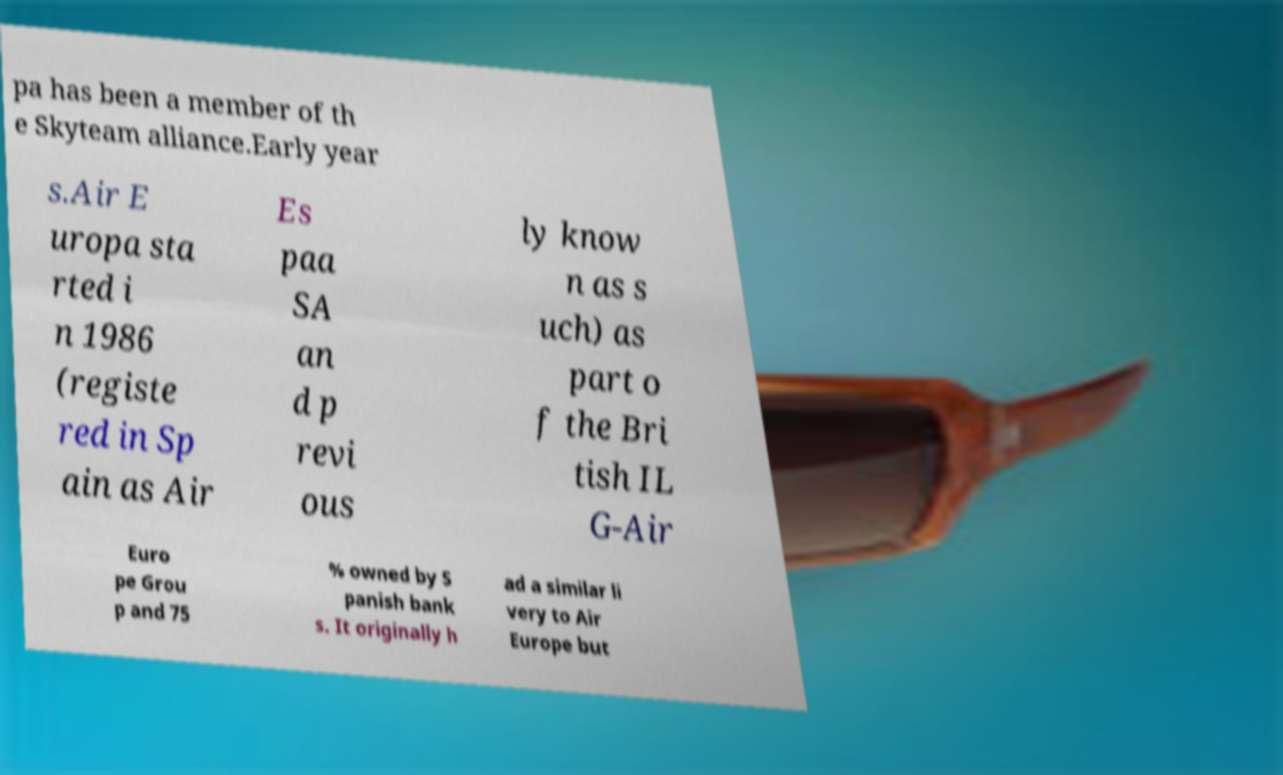Could you extract and type out the text from this image? pa has been a member of th e Skyteam alliance.Early year s.Air E uropa sta rted i n 1986 (registe red in Sp ain as Air Es paa SA an d p revi ous ly know n as s uch) as part o f the Bri tish IL G-Air Euro pe Grou p and 75 % owned by S panish bank s. It originally h ad a similar li very to Air Europe but 